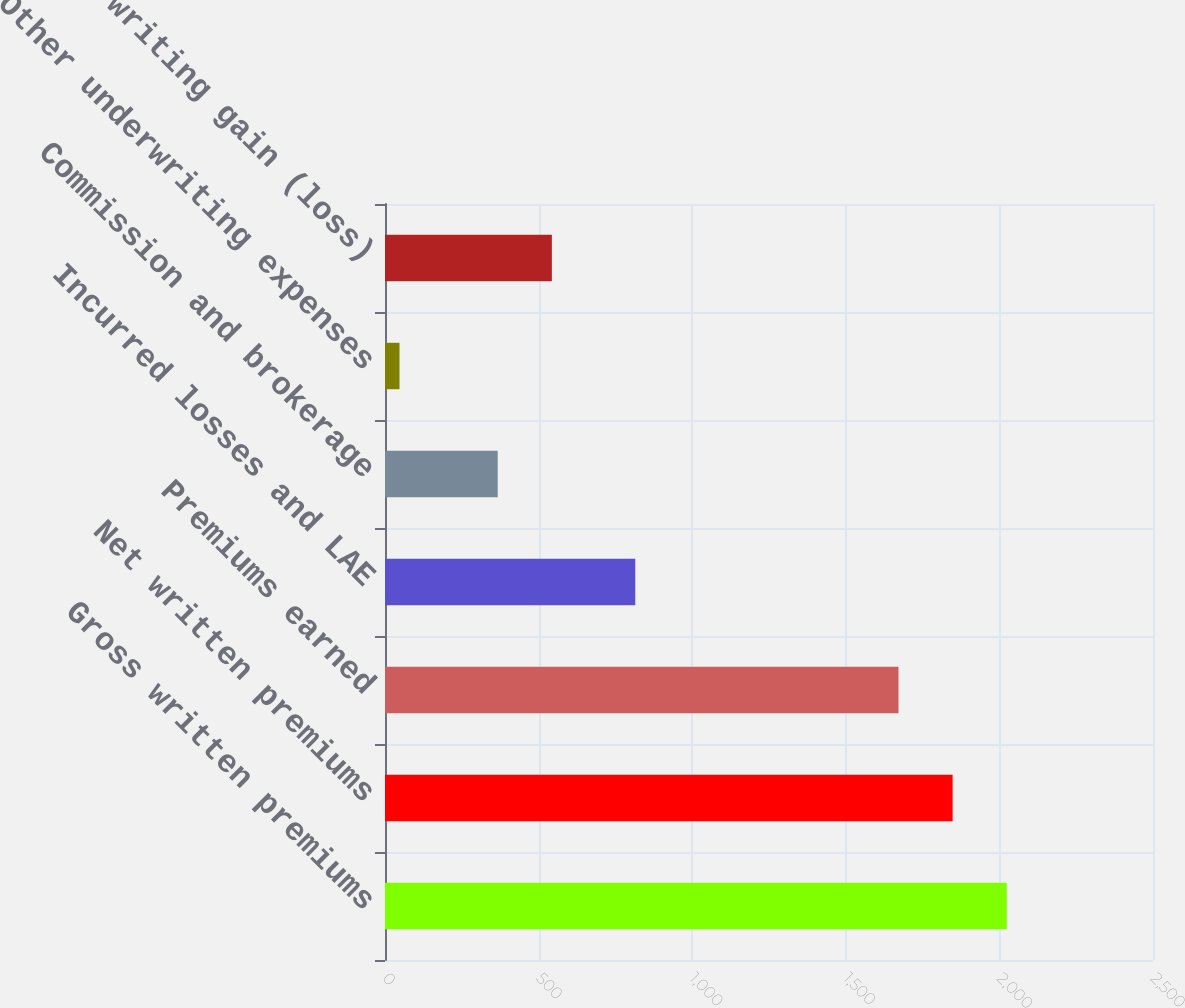Convert chart. <chart><loc_0><loc_0><loc_500><loc_500><bar_chart><fcel>Gross written premiums<fcel>Net written premiums<fcel>Premiums earned<fcel>Incurred losses and LAE<fcel>Commission and brokerage<fcel>Other underwriting expenses<fcel>Underwriting gain (loss)<nl><fcel>2024<fcel>1847.75<fcel>1671.5<fcel>814.7<fcel>366.9<fcel>47.2<fcel>543.15<nl></chart> 